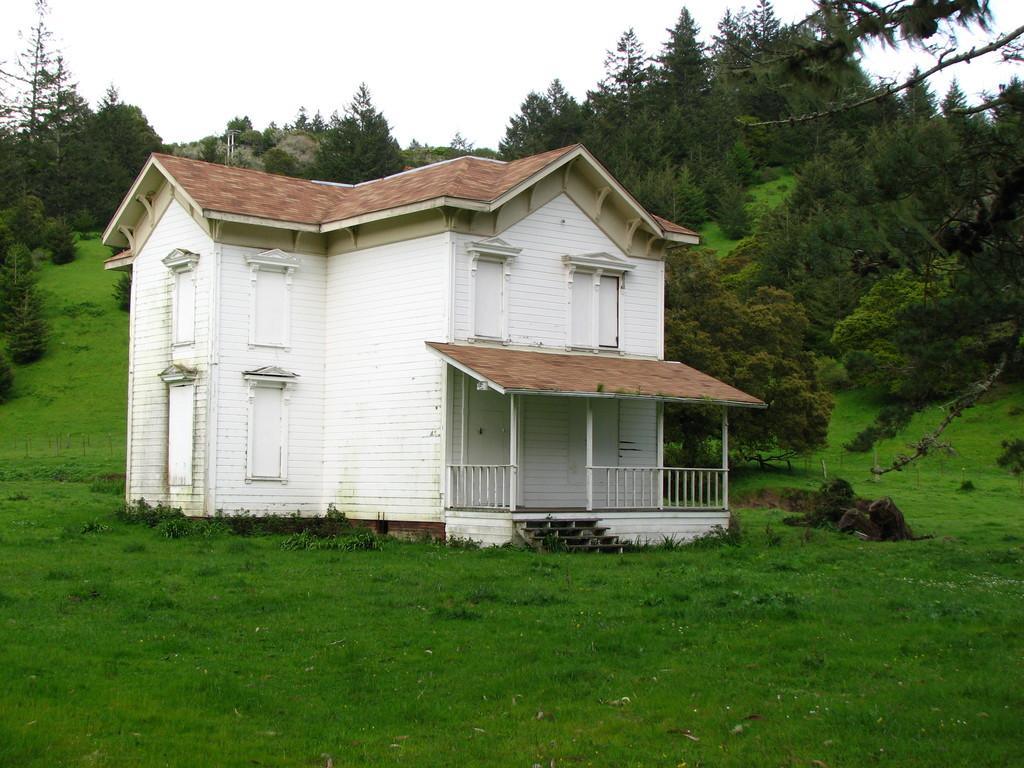What type of house is in the image? There is a house with roof tiles in the image. Where is the house located in the image? The house is in the center of the image. What is at the bottom of the image? There is grass at the bottom of the image. What can be seen in the background of the image? There are trees and the sky visible in the background of the image. What rule is being discussed in the image? There is no discussion or rule present in the image; it features a house, grass, trees, and the sky. 